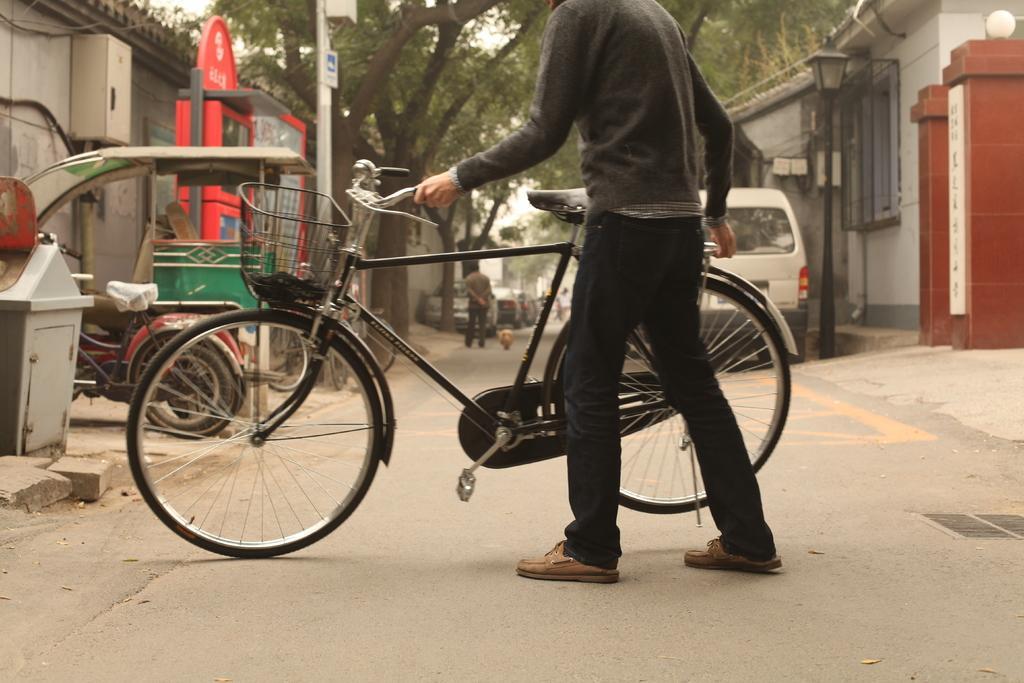Can you describe this image briefly? In this image I can see a person holding a bicycle. There are other people and vehicles at the back. There are buildings and trees on the either sides. 